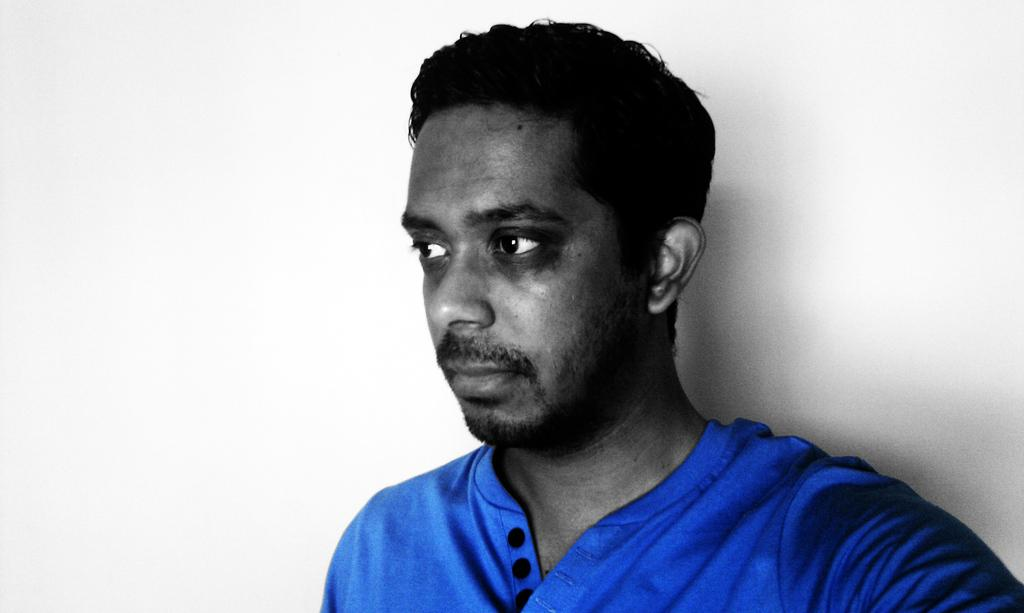Who is present in the image? There is a man in the picture. What is the man wearing in the image? The man is wearing a blue t-shirt. Where is the man located in the image? The man is standing near a wall. What type of plastic material is the man holding in the image? There is no plastic material visible in the image. 